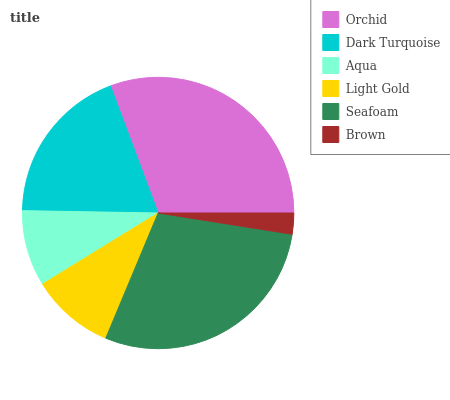Is Brown the minimum?
Answer yes or no. Yes. Is Orchid the maximum?
Answer yes or no. Yes. Is Dark Turquoise the minimum?
Answer yes or no. No. Is Dark Turquoise the maximum?
Answer yes or no. No. Is Orchid greater than Dark Turquoise?
Answer yes or no. Yes. Is Dark Turquoise less than Orchid?
Answer yes or no. Yes. Is Dark Turquoise greater than Orchid?
Answer yes or no. No. Is Orchid less than Dark Turquoise?
Answer yes or no. No. Is Dark Turquoise the high median?
Answer yes or no. Yes. Is Light Gold the low median?
Answer yes or no. Yes. Is Aqua the high median?
Answer yes or no. No. Is Brown the low median?
Answer yes or no. No. 